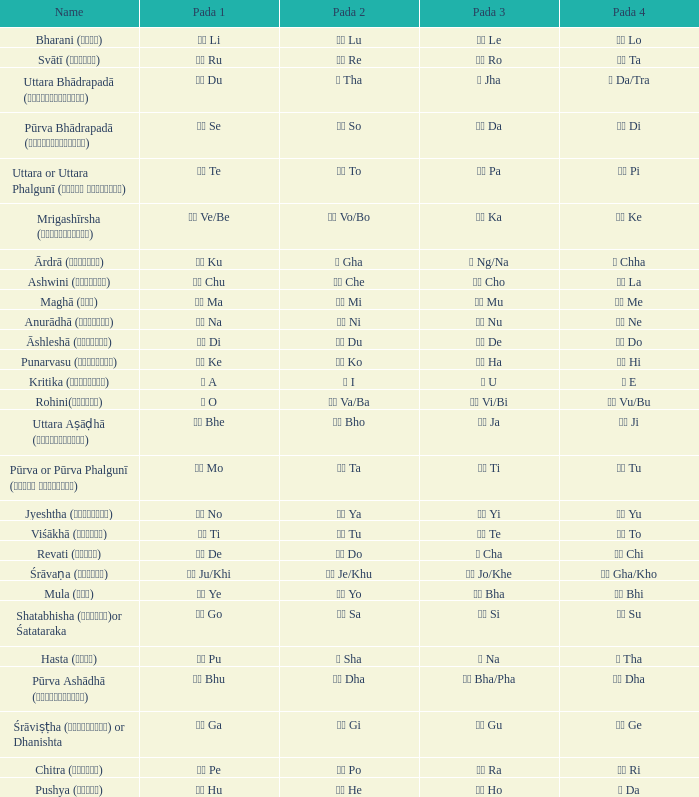Which Pada 3 has a Pada 1 of टे te? पा Pa. 